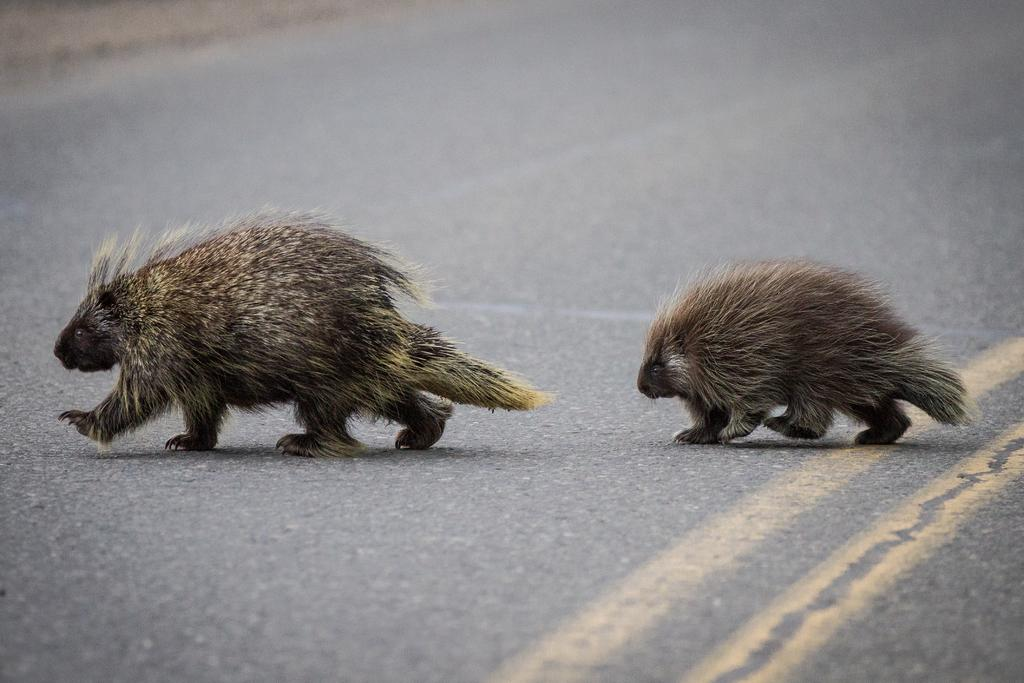What types of living organisms can be seen in the image? There are animals in the image. What are the animals doing in the image? The animals are walking on the road. What type of scarf is the owl wearing in the image? There is no owl or scarf present in the image. What type of band is playing music in the image? There is no band or music present in the image. 